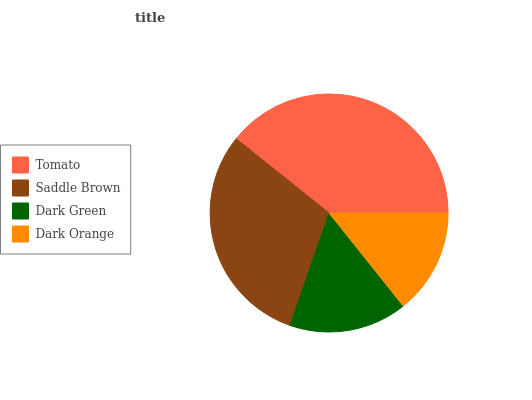Is Dark Orange the minimum?
Answer yes or no. Yes. Is Tomato the maximum?
Answer yes or no. Yes. Is Saddle Brown the minimum?
Answer yes or no. No. Is Saddle Brown the maximum?
Answer yes or no. No. Is Tomato greater than Saddle Brown?
Answer yes or no. Yes. Is Saddle Brown less than Tomato?
Answer yes or no. Yes. Is Saddle Brown greater than Tomato?
Answer yes or no. No. Is Tomato less than Saddle Brown?
Answer yes or no. No. Is Saddle Brown the high median?
Answer yes or no. Yes. Is Dark Green the low median?
Answer yes or no. Yes. Is Dark Green the high median?
Answer yes or no. No. Is Saddle Brown the low median?
Answer yes or no. No. 